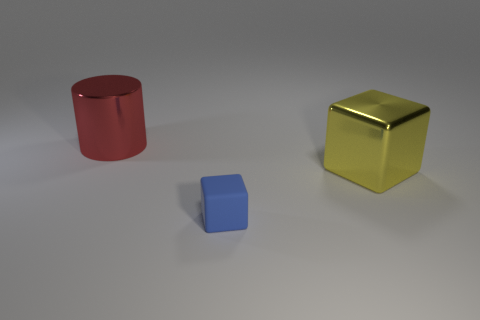What materials seem to be represented by the objects in this image? The objects in the image appear to be rendered to simulate metallic materials, with the red and yellow objects exhibiting a glossy, reflective surface that suggests a metal-like texture, and the blue cube having a matte finish. 